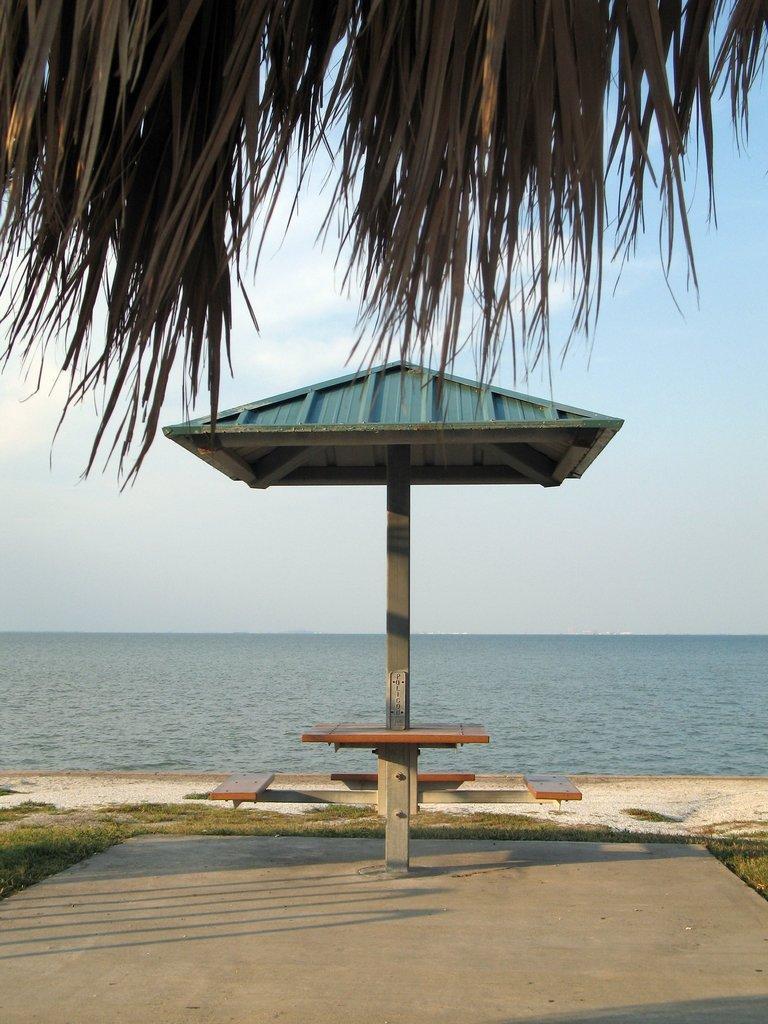Please provide a concise description of this image. This image is taken outdoors. At the bottom of the image there is a floor. In the background there is a sea. In the middle of the image there is a roof. At the top of the image there is a sky with clouds and there are a few leaves of a coconut tree. 